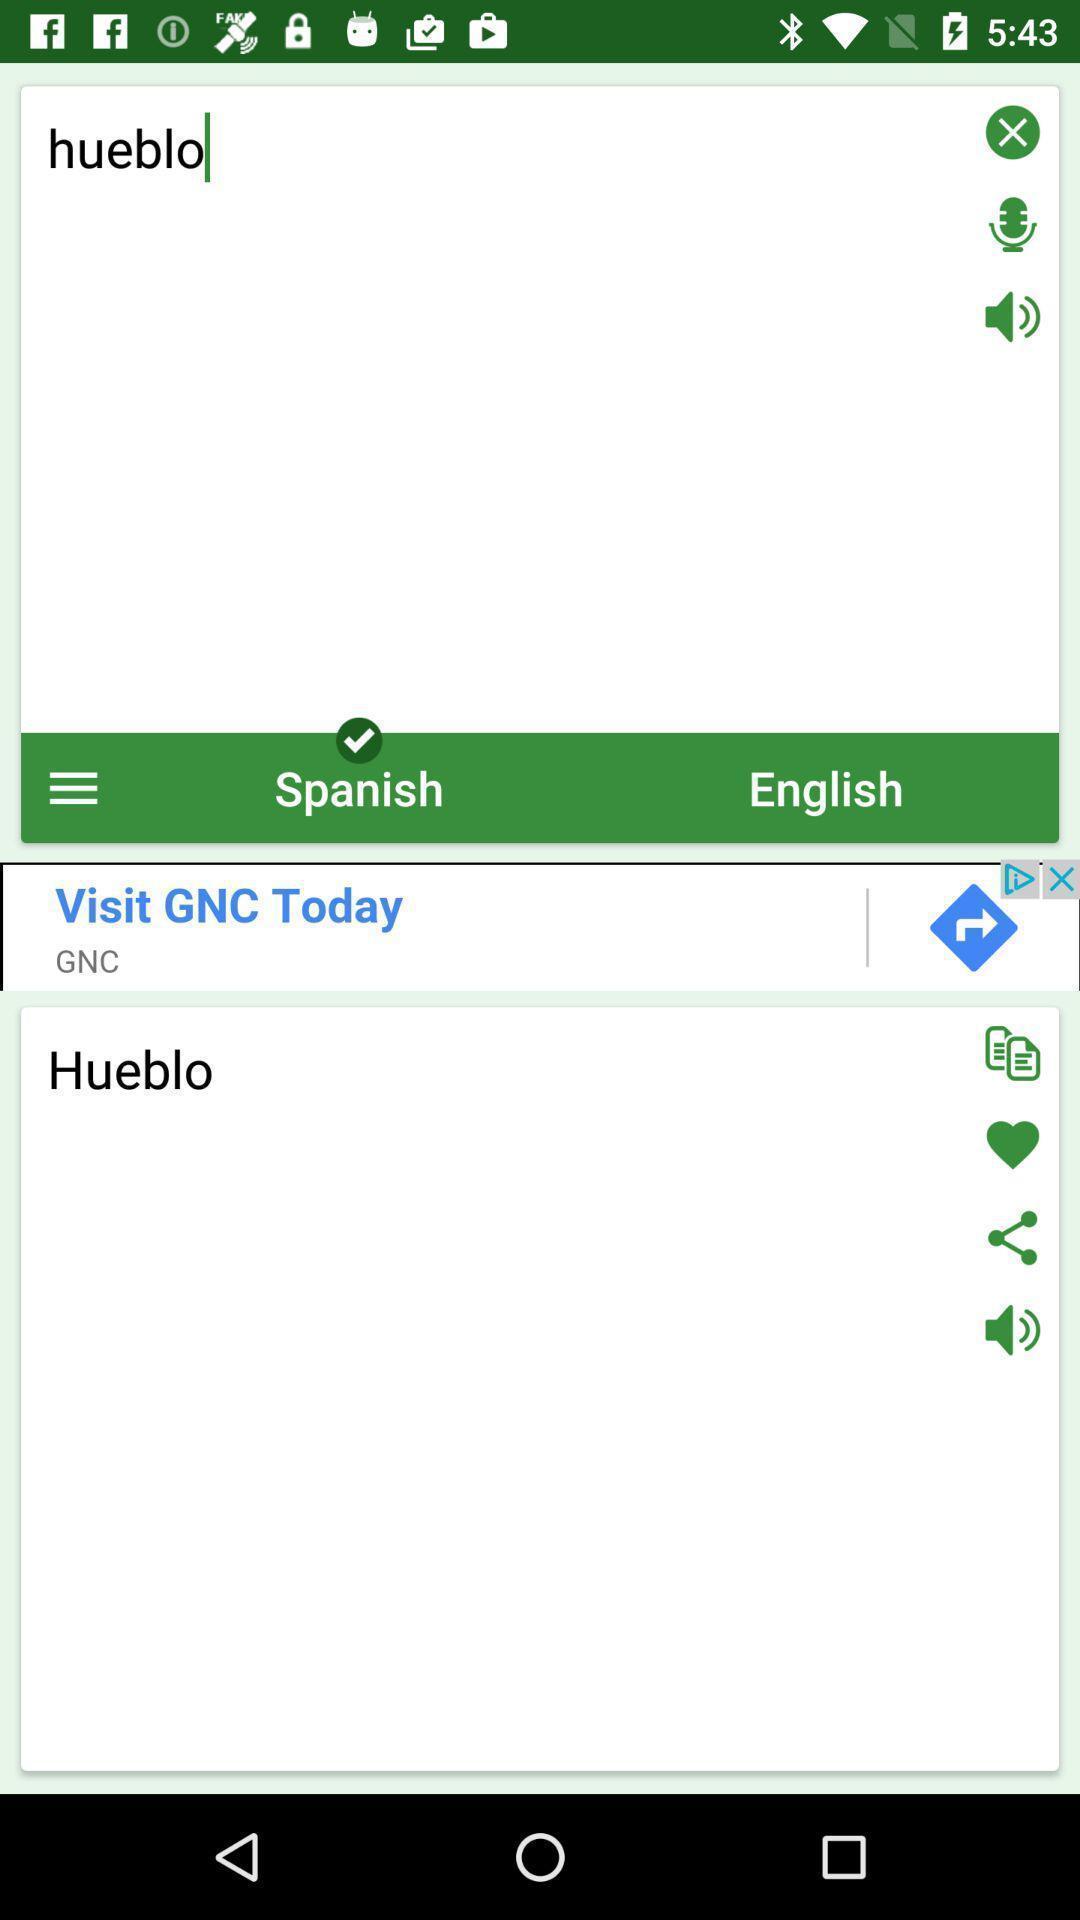Provide a description of this screenshot. Screen displaying the page of a translation app. 